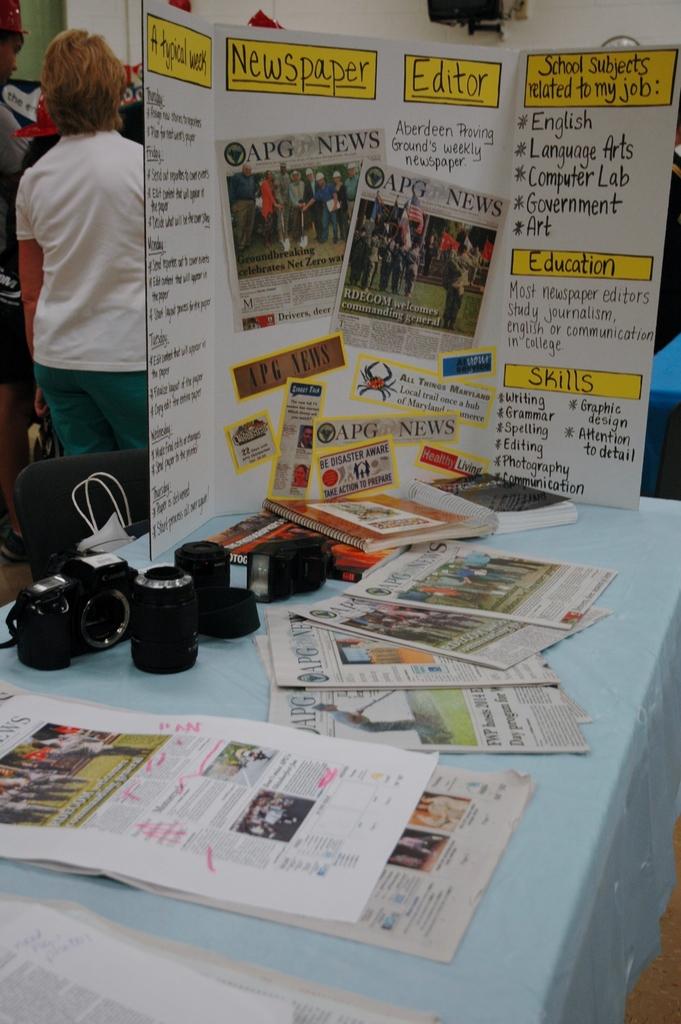Which school subjects are related to the job of a newspaper editor?
Keep it short and to the point. English, language arts, computer lab, government, art. What is written in the first yellow box, farthest left?
Keep it short and to the point. A typical week. 